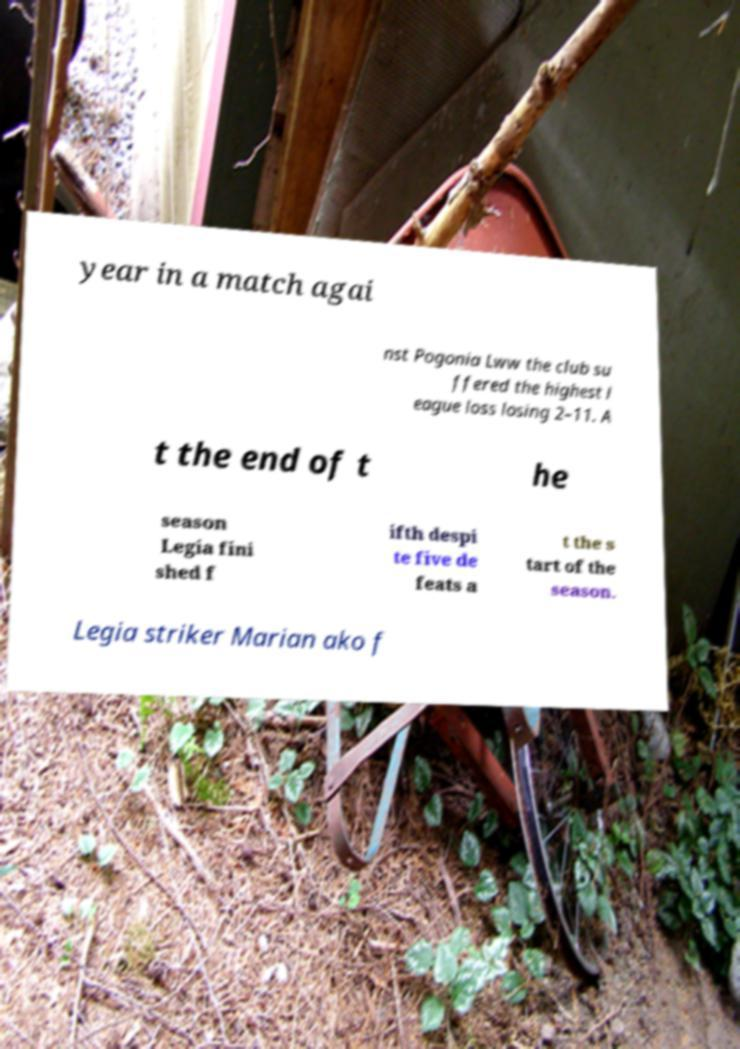For documentation purposes, I need the text within this image transcribed. Could you provide that? year in a match agai nst Pogonia Lww the club su ffered the highest l eague loss losing 2–11. A t the end of t he season Legia fini shed f ifth despi te five de feats a t the s tart of the season. Legia striker Marian ako f 